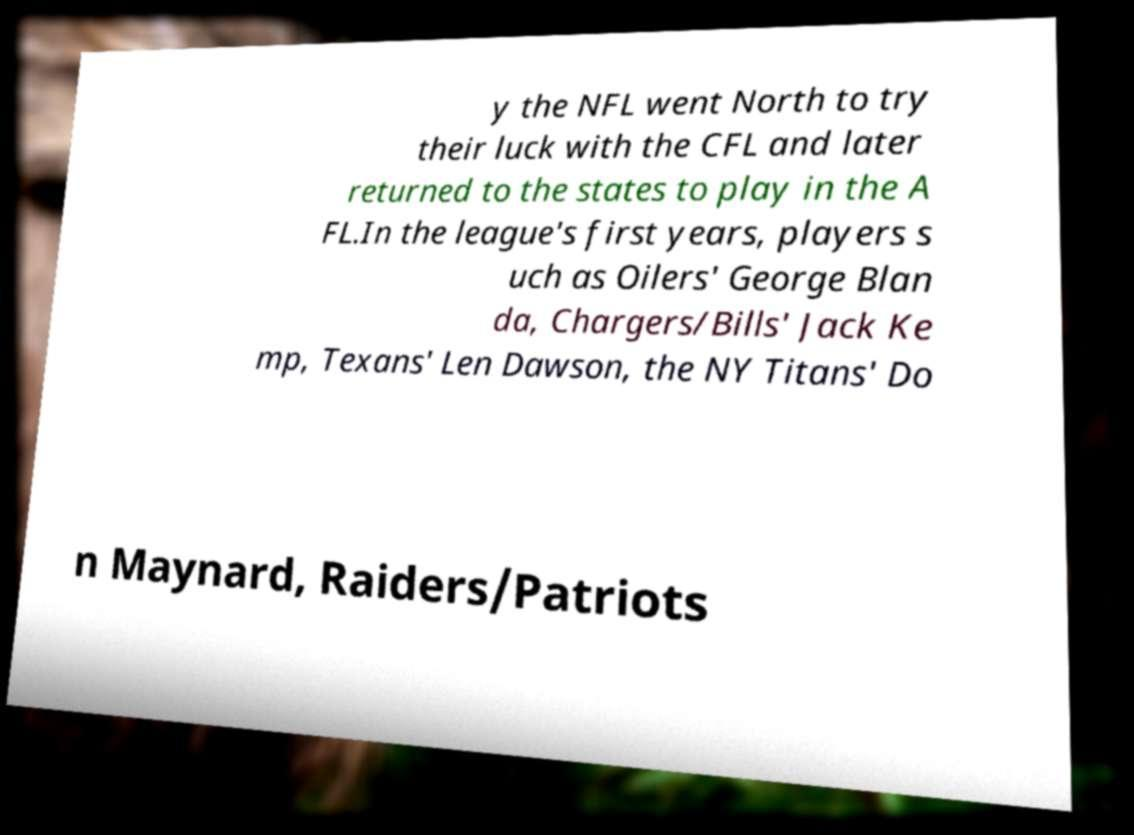Please identify and transcribe the text found in this image. y the NFL went North to try their luck with the CFL and later returned to the states to play in the A FL.In the league's first years, players s uch as Oilers' George Blan da, Chargers/Bills' Jack Ke mp, Texans' Len Dawson, the NY Titans' Do n Maynard, Raiders/Patriots 